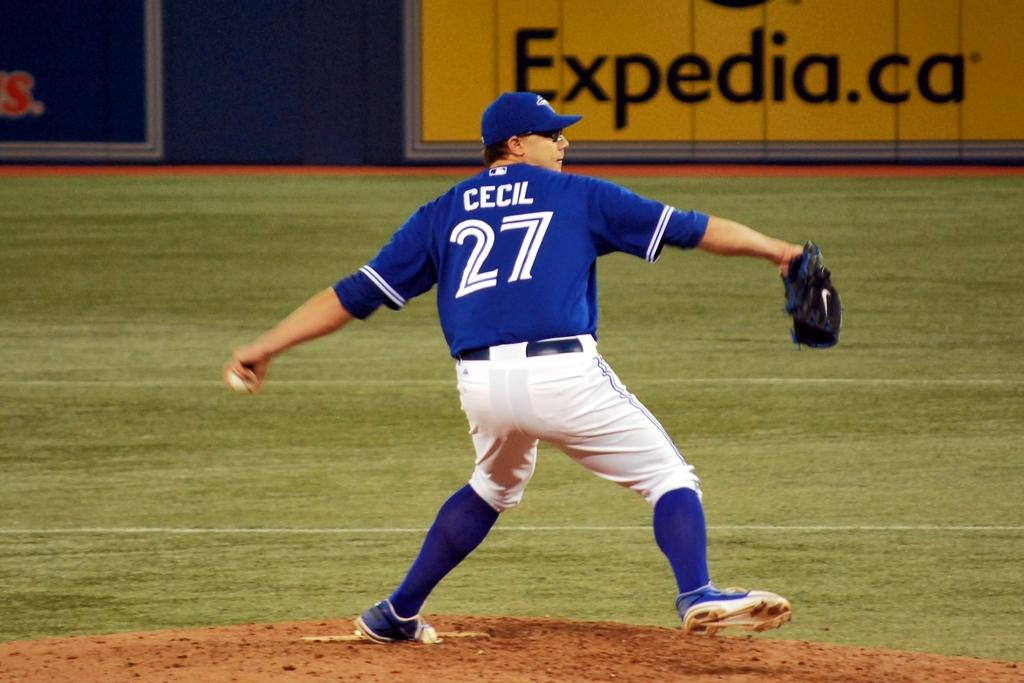Provide a one-sentence caption for the provided image. A baseball player is wearing a jersey with Cecil on the back. 